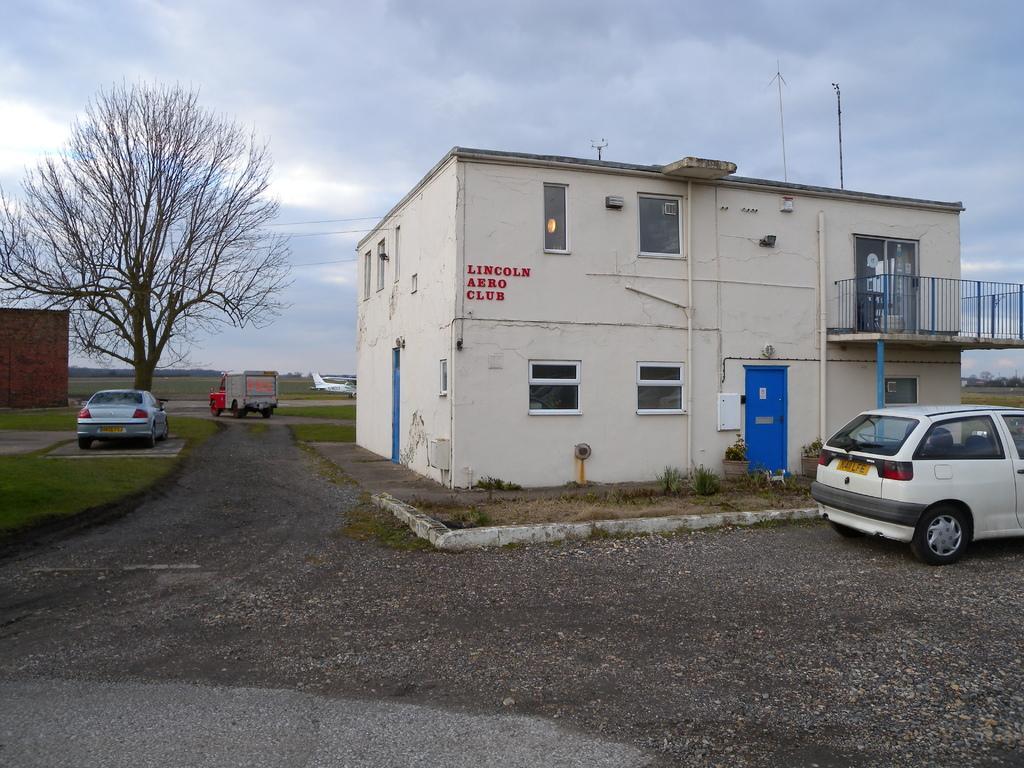Can you describe this image briefly? In the center of the image we can see a building with group of windows and doors and a metal railing on it. To the right side of the image we can see a vehicle parked on the road. To the left side of the image we can see two vehicles and a tree. In the background, we can see an airplane and the cloudy sky. 